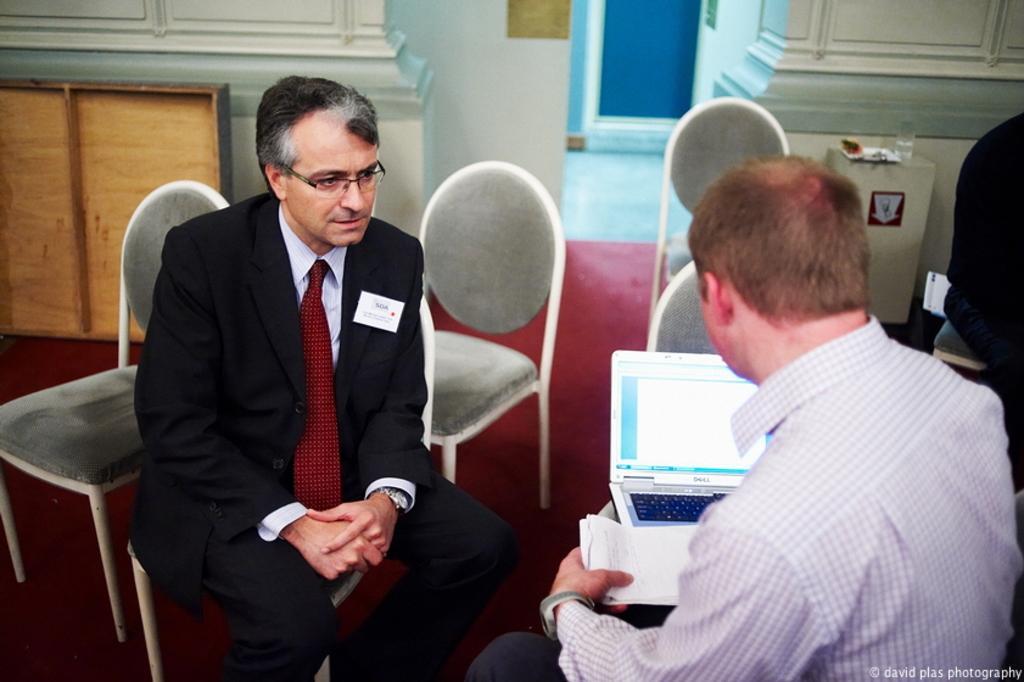How would you summarize this image in a sentence or two? On the left side of the image we can see a man is sitting on a chair. On the right side of the image we can see two persons are sitting on the chairs and a man is holding a paper, in-front of him we can see a laptop. In the background of the image we can see the chairs, cupboard, wall, door, table. On the we can see a glass and other objects. In the background of the image we can see the floor. In the bottom right corner we can see the text. 